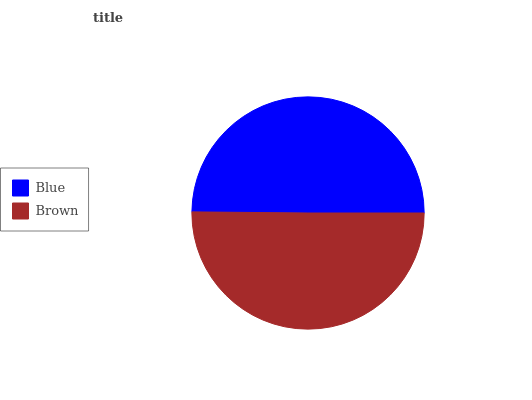Is Blue the minimum?
Answer yes or no. Yes. Is Brown the maximum?
Answer yes or no. Yes. Is Brown the minimum?
Answer yes or no. No. Is Brown greater than Blue?
Answer yes or no. Yes. Is Blue less than Brown?
Answer yes or no. Yes. Is Blue greater than Brown?
Answer yes or no. No. Is Brown less than Blue?
Answer yes or no. No. Is Brown the high median?
Answer yes or no. Yes. Is Blue the low median?
Answer yes or no. Yes. Is Blue the high median?
Answer yes or no. No. Is Brown the low median?
Answer yes or no. No. 